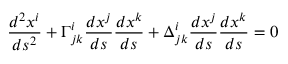<formula> <loc_0><loc_0><loc_500><loc_500>{ \frac { d ^ { 2 } x ^ { i } } { d s ^ { 2 } } } + \Gamma _ { j k } ^ { i } { \frac { d x ^ { j } } { d s } } { \frac { d x ^ { k } } { d s } } + \Delta _ { j k } ^ { i } { \frac { d x ^ { j } } { d s } } { \frac { d x ^ { k } } { d s } } = 0</formula> 